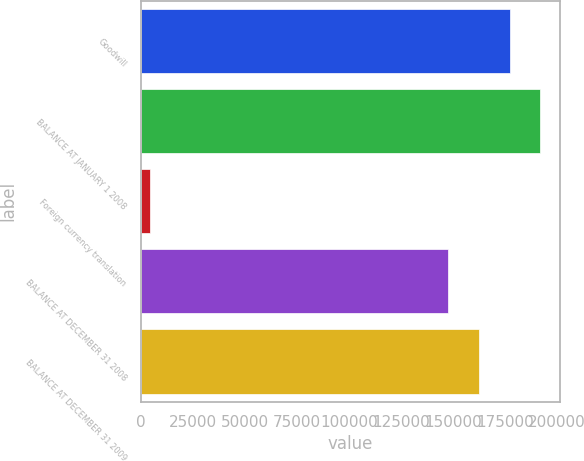<chart> <loc_0><loc_0><loc_500><loc_500><bar_chart><fcel>Goodwill<fcel>BALANCE AT JANUARY 1 2008<fcel>Foreign currency translation<fcel>BALANCE AT DECEMBER 31 2008<fcel>BALANCE AT DECEMBER 31 2009<nl><fcel>177062<fcel>191818<fcel>4155<fcel>147552<fcel>162307<nl></chart> 